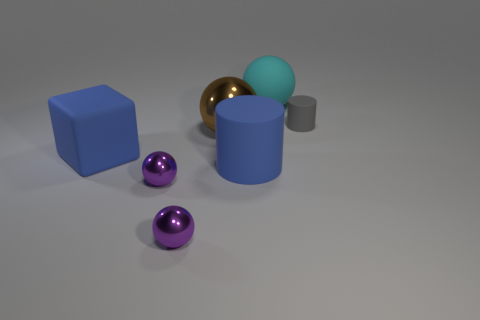There is a tiny gray matte object; what shape is it?
Give a very brief answer. Cylinder. Do the big block that is left of the large cylinder and the big cylinder have the same color?
Your response must be concise. Yes. What number of metal things are either brown spheres or cylinders?
Your response must be concise. 1. What is the color of the tiny object that is the same material as the large cyan thing?
Offer a very short reply. Gray. What number of cylinders are tiny purple metallic objects or brown shiny things?
Make the answer very short. 0. How many objects are either large cyan objects or large balls in front of the small gray matte thing?
Give a very brief answer. 2. Are there any small gray metal balls?
Make the answer very short. No. How many things have the same color as the big matte cylinder?
Your response must be concise. 1. What material is the large object that is the same color as the large matte cylinder?
Offer a terse response. Rubber. There is a cylinder that is on the right side of the large ball behind the gray object; what size is it?
Your response must be concise. Small. 